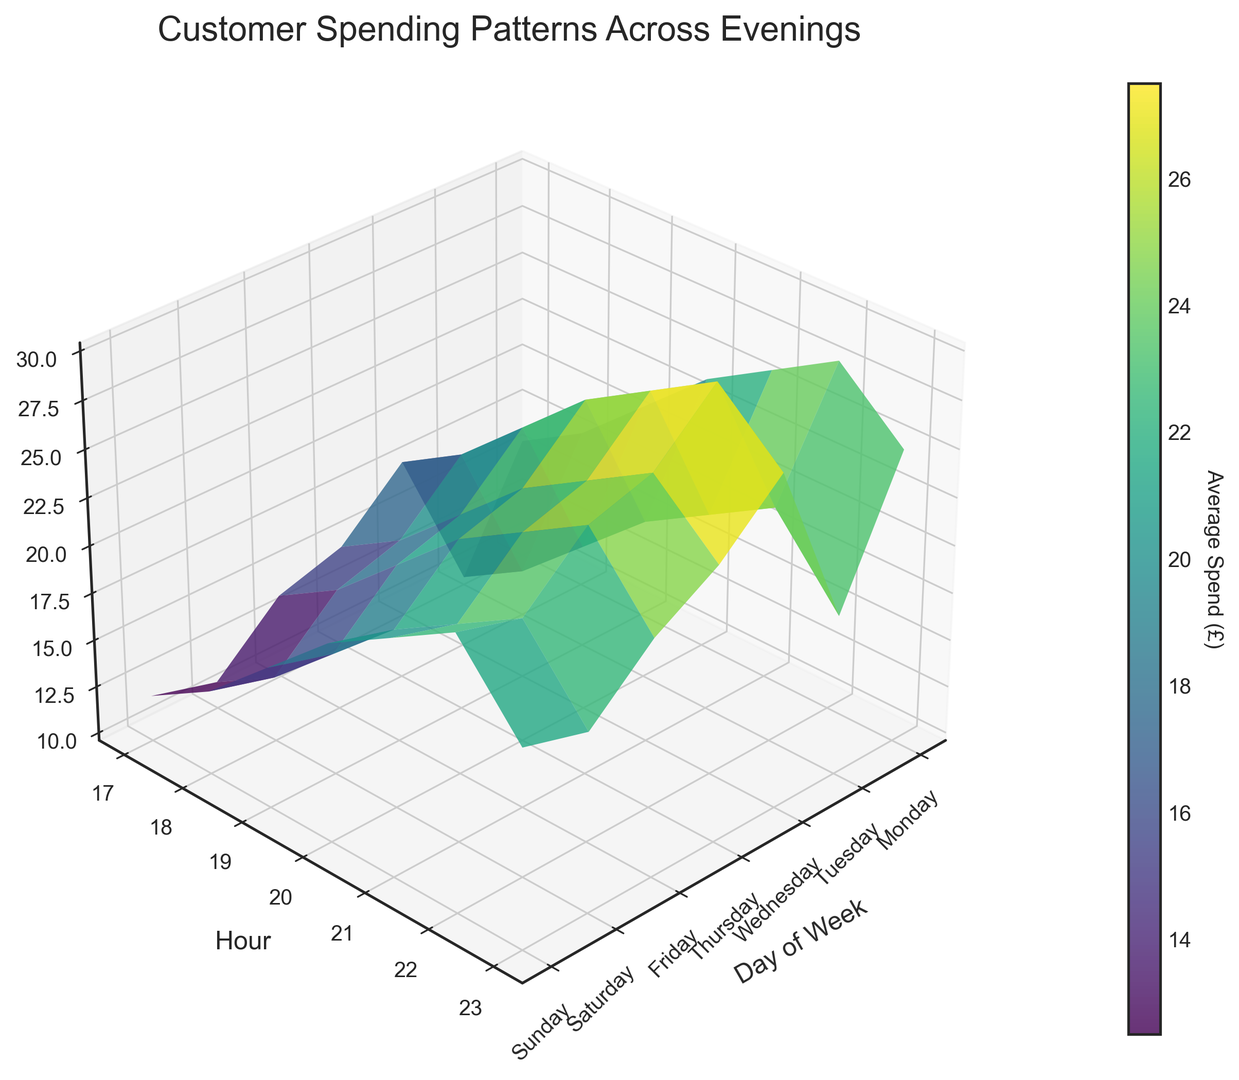When is the average spend highest on a Friday? Look for Friday on the X-axis and identify the peak value along the Z-axis to determine which hour has the highest average spend. The peak occurs at £28 at 22:00.
Answer: 22:00 How does the average spend on a Saturday at 21:00 compare to that on a Wednesday at 21:00? Identify the spend at 21:00 on both Saturday and Wednesday from the Z-axis. Saturday's spend is £28, while Wednesday's is £22. Thus, Saturday's spend is £6 higher.
Answer: £6 higher What is the average spend trend from 17:00 to 23:00 on a Thursday? Check the spend values along the Y-axis from 17:00 to 23:00 for Thursday on the Z-axis. The values are £14, £16, £19, £22, £24, £26, and £22. The trend shows a steady increase till 22:00, followed by a drop at 23:00.
Answer: Increase, then drop Compare the spend at 20:00 on a Tuesday to 20:00 on a Sunday. Which is higher and by how much? Check the spend on the Z-axis for Tuesday at 20:00 (£19) and Sunday at 20:00 (£23). The Sunday spend is higher by £4.
Answer: Sunday by £4 Which day of the week has the lowest average spend at 22:00? Move along the Y-axis to 22:00 and compare the Z-axis values for all the days. The lowest value at 22:00 is £22 on Monday.
Answer: Monday What is the difference in average spend between the peaks on Friday and Saturday? Identify the highest Z-axis values for Friday (£28) and Saturday (£30). The difference between the peaks is £2.
Answer: £2 During which hour is the average spend highest across the entire week? Scan through the Z-axis values for all days and hours to find the peak. The highest spend is £30, which occurs on Saturday at 22:00.
Answer: 22:00 What is the average spend on Thursday at 18:00? Locate Thursday on the X-axis and follow the 18:00 line on the Y-axis to their intersection on the Z-axis, showing the spend of £16.
Answer: £16 